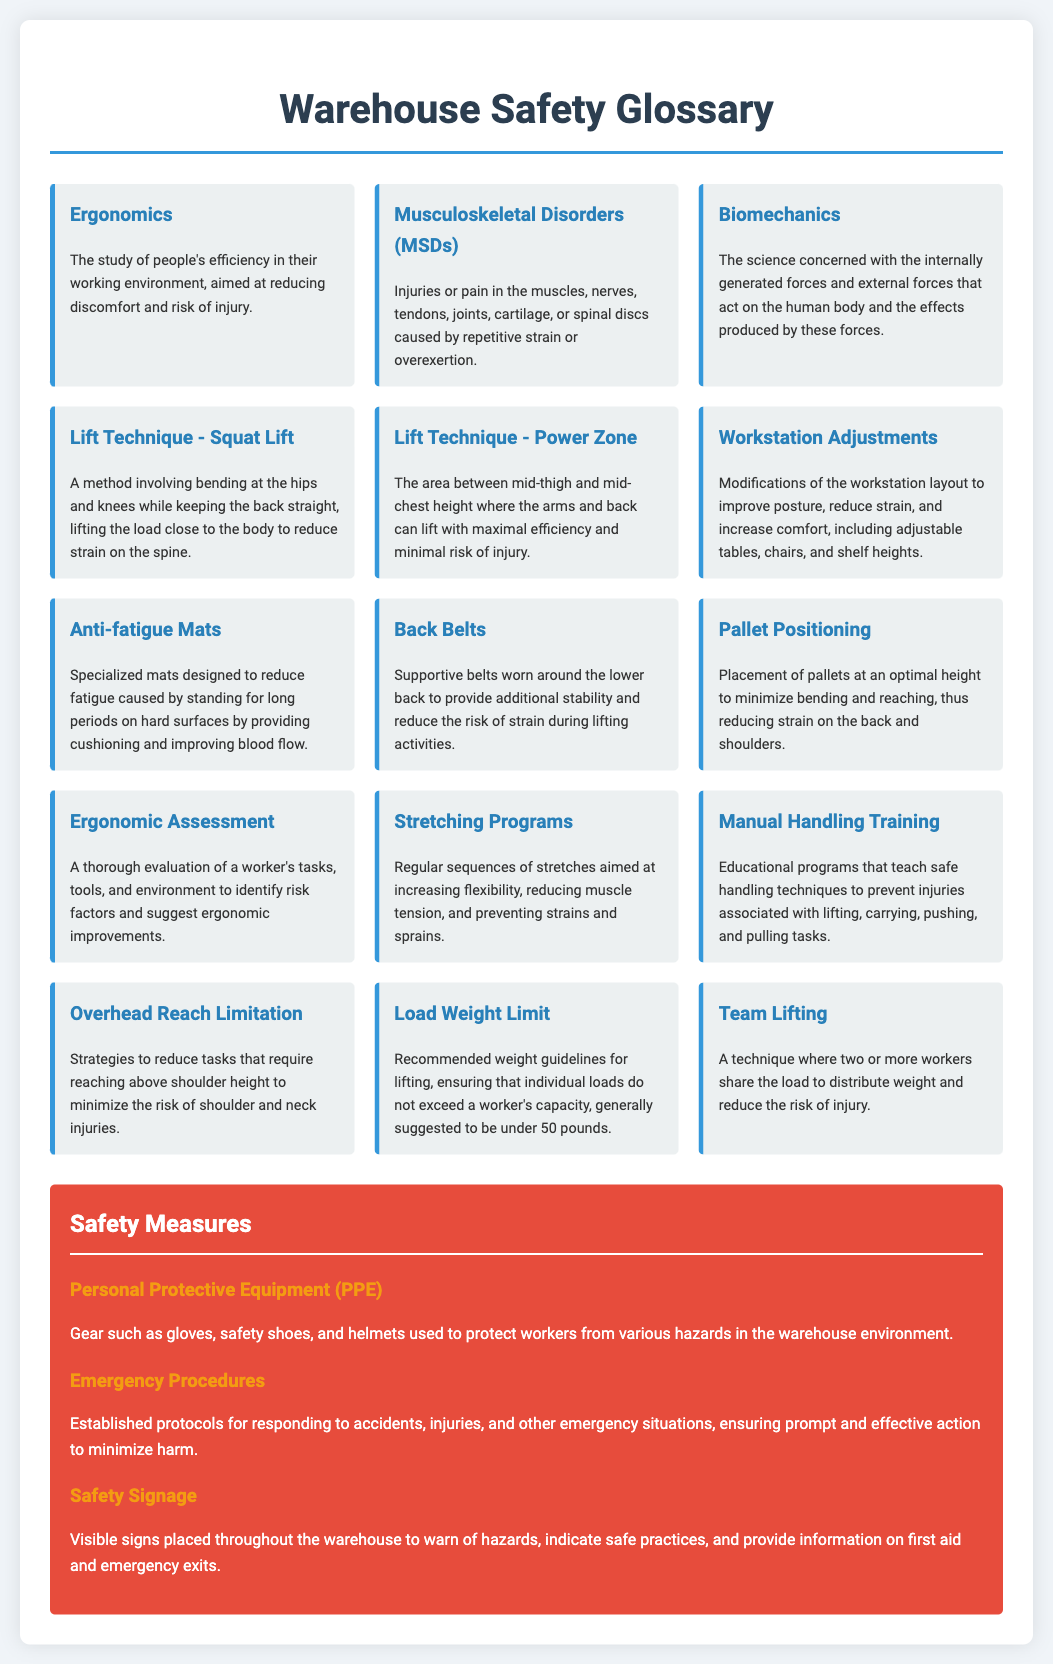What is ergonomics? Ergonomics is defined in the document as the study of people's efficiency in their working environment, aimed at reducing discomfort and risk of injury.
Answer: The study of people's efficiency in their working environment What are Musculoskeletal Disorders (MSDs)? The document describes Musculoskeletal Disorders (MSDs) as injuries or pain in various parts of the body caused by repetitive strain or overexertion.
Answer: Injuries or pain in the muscles, nerves, tendons, joints, cartilage, or spinal discs What is the optimal Lift Technique mentioned? The document identifies the Squat Lift as an important optimal lifting technique to reduce strain on the spine.
Answer: Squat Lift What does the Power Zone refer to? The document explains the Power Zone as the area between mid-thigh and mid-chest height where lifting efficiency is maximized.
Answer: Between mid-thigh and mid-chest height What is the recommended Load Weight Limit? According to the document, the recommended load weight limit for lifting is generally suggested to be under 50 pounds.
Answer: Under 50 pounds What are Anti-fatigue Mats designed for? The document states that Anti-fatigue Mats are designed to reduce fatigue caused by standing for long periods on hard surfaces.
Answer: To reduce fatigue caused by standing What type of training is provided to prevent lifting injuries? The document mentions Manual Handling Training as a type of training provided to prevent injuries related to lifting.
Answer: Manual Handling Training What is an Ergonomic Assessment? The document describes an Ergonomic Assessment as a thorough evaluation of a worker's tasks, tools, and environment to identify risk factors.
Answer: A thorough evaluation of a worker's tasks, tools, and environment What is one measure for team lifting? The document suggests Team Lifting as a technique where two or more workers share the load to reduce the risk of injury.
Answer: Team Lifting 